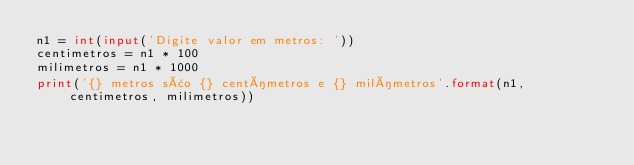<code> <loc_0><loc_0><loc_500><loc_500><_Python_>n1 = int(input('Digite valor em metros: '))
centimetros = n1 * 100
milimetros = n1 * 1000
print('{} metros são {} centímetros e {} milímetros'.format(n1, centimetros, milimetros))</code> 